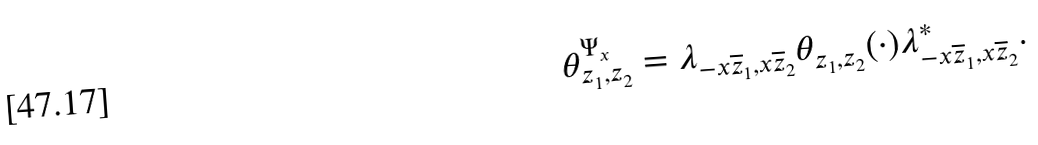Convert formula to latex. <formula><loc_0><loc_0><loc_500><loc_500>\theta _ { z _ { 1 } , z _ { 2 } } ^ { \Psi _ { x } } = \lambda _ { - x \overline { z } _ { 1 } , x \overline { z } _ { 2 } } \theta _ { z _ { 1 } , z _ { 2 } } ( \cdot ) \lambda ^ { * } _ { - x \overline { z } _ { 1 } , x \overline { z } _ { 2 } } .</formula> 